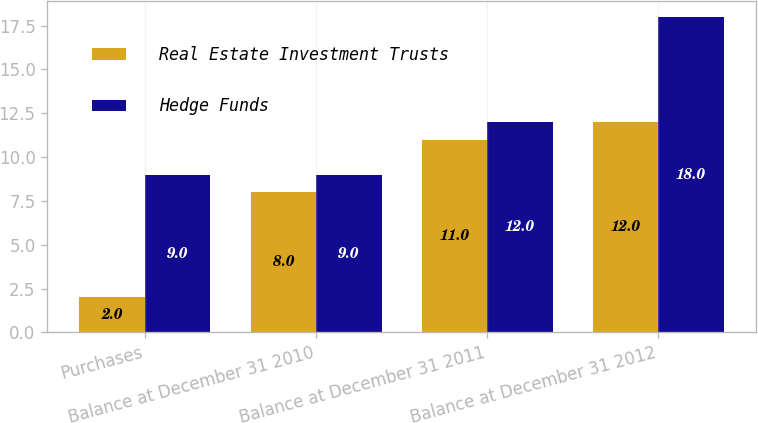Convert chart. <chart><loc_0><loc_0><loc_500><loc_500><stacked_bar_chart><ecel><fcel>Purchases<fcel>Balance at December 31 2010<fcel>Balance at December 31 2011<fcel>Balance at December 31 2012<nl><fcel>Real Estate Investment Trusts<fcel>2<fcel>8<fcel>11<fcel>12<nl><fcel>Hedge Funds<fcel>9<fcel>9<fcel>12<fcel>18<nl></chart> 